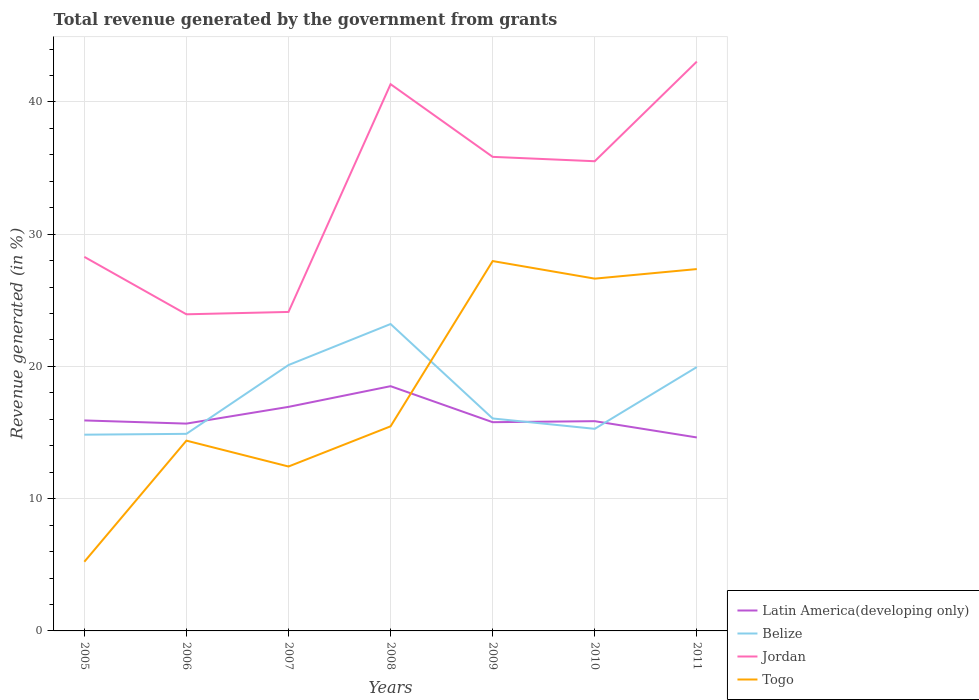Does the line corresponding to Togo intersect with the line corresponding to Jordan?
Provide a succinct answer. No. Across all years, what is the maximum total revenue generated in Togo?
Ensure brevity in your answer.  5.23. What is the total total revenue generated in Jordan in the graph?
Your answer should be very brief. -7.54. What is the difference between the highest and the second highest total revenue generated in Latin America(developing only)?
Ensure brevity in your answer.  3.88. Is the total revenue generated in Latin America(developing only) strictly greater than the total revenue generated in Jordan over the years?
Provide a short and direct response. Yes. Are the values on the major ticks of Y-axis written in scientific E-notation?
Your answer should be compact. No. What is the title of the graph?
Offer a terse response. Total revenue generated by the government from grants. Does "Cabo Verde" appear as one of the legend labels in the graph?
Your response must be concise. No. What is the label or title of the X-axis?
Ensure brevity in your answer.  Years. What is the label or title of the Y-axis?
Provide a succinct answer. Revenue generated (in %). What is the Revenue generated (in %) in Latin America(developing only) in 2005?
Your response must be concise. 15.92. What is the Revenue generated (in %) in Belize in 2005?
Provide a succinct answer. 14.84. What is the Revenue generated (in %) of Jordan in 2005?
Keep it short and to the point. 28.29. What is the Revenue generated (in %) in Togo in 2005?
Ensure brevity in your answer.  5.23. What is the Revenue generated (in %) of Latin America(developing only) in 2006?
Ensure brevity in your answer.  15.68. What is the Revenue generated (in %) in Belize in 2006?
Give a very brief answer. 14.9. What is the Revenue generated (in %) in Jordan in 2006?
Offer a very short reply. 23.94. What is the Revenue generated (in %) of Togo in 2006?
Offer a terse response. 14.39. What is the Revenue generated (in %) in Latin America(developing only) in 2007?
Keep it short and to the point. 16.94. What is the Revenue generated (in %) in Belize in 2007?
Offer a very short reply. 20.11. What is the Revenue generated (in %) in Jordan in 2007?
Make the answer very short. 24.12. What is the Revenue generated (in %) in Togo in 2007?
Offer a terse response. 12.43. What is the Revenue generated (in %) of Latin America(developing only) in 2008?
Keep it short and to the point. 18.51. What is the Revenue generated (in %) in Belize in 2008?
Keep it short and to the point. 23.21. What is the Revenue generated (in %) of Jordan in 2008?
Your response must be concise. 41.35. What is the Revenue generated (in %) in Togo in 2008?
Offer a terse response. 15.47. What is the Revenue generated (in %) of Latin America(developing only) in 2009?
Your answer should be very brief. 15.78. What is the Revenue generated (in %) in Belize in 2009?
Your answer should be compact. 16.07. What is the Revenue generated (in %) of Jordan in 2009?
Offer a very short reply. 35.85. What is the Revenue generated (in %) of Togo in 2009?
Your answer should be compact. 27.97. What is the Revenue generated (in %) of Latin America(developing only) in 2010?
Provide a succinct answer. 15.86. What is the Revenue generated (in %) in Belize in 2010?
Your response must be concise. 15.28. What is the Revenue generated (in %) in Jordan in 2010?
Offer a very short reply. 35.52. What is the Revenue generated (in %) in Togo in 2010?
Offer a terse response. 26.64. What is the Revenue generated (in %) in Latin America(developing only) in 2011?
Your response must be concise. 14.63. What is the Revenue generated (in %) in Belize in 2011?
Offer a terse response. 19.95. What is the Revenue generated (in %) of Jordan in 2011?
Your answer should be very brief. 43.05. What is the Revenue generated (in %) in Togo in 2011?
Ensure brevity in your answer.  27.36. Across all years, what is the maximum Revenue generated (in %) of Latin America(developing only)?
Your answer should be very brief. 18.51. Across all years, what is the maximum Revenue generated (in %) in Belize?
Your answer should be compact. 23.21. Across all years, what is the maximum Revenue generated (in %) in Jordan?
Offer a very short reply. 43.05. Across all years, what is the maximum Revenue generated (in %) in Togo?
Provide a short and direct response. 27.97. Across all years, what is the minimum Revenue generated (in %) in Latin America(developing only)?
Your answer should be very brief. 14.63. Across all years, what is the minimum Revenue generated (in %) in Belize?
Your response must be concise. 14.84. Across all years, what is the minimum Revenue generated (in %) of Jordan?
Provide a succinct answer. 23.94. Across all years, what is the minimum Revenue generated (in %) of Togo?
Ensure brevity in your answer.  5.23. What is the total Revenue generated (in %) in Latin America(developing only) in the graph?
Provide a short and direct response. 113.32. What is the total Revenue generated (in %) in Belize in the graph?
Give a very brief answer. 124.36. What is the total Revenue generated (in %) of Jordan in the graph?
Provide a short and direct response. 232.12. What is the total Revenue generated (in %) of Togo in the graph?
Make the answer very short. 129.5. What is the difference between the Revenue generated (in %) in Latin America(developing only) in 2005 and that in 2006?
Provide a succinct answer. 0.24. What is the difference between the Revenue generated (in %) of Belize in 2005 and that in 2006?
Provide a short and direct response. -0.06. What is the difference between the Revenue generated (in %) of Jordan in 2005 and that in 2006?
Ensure brevity in your answer.  4.34. What is the difference between the Revenue generated (in %) in Togo in 2005 and that in 2006?
Keep it short and to the point. -9.16. What is the difference between the Revenue generated (in %) in Latin America(developing only) in 2005 and that in 2007?
Make the answer very short. -1.03. What is the difference between the Revenue generated (in %) in Belize in 2005 and that in 2007?
Provide a short and direct response. -5.27. What is the difference between the Revenue generated (in %) of Jordan in 2005 and that in 2007?
Provide a succinct answer. 4.16. What is the difference between the Revenue generated (in %) of Togo in 2005 and that in 2007?
Ensure brevity in your answer.  -7.2. What is the difference between the Revenue generated (in %) of Latin America(developing only) in 2005 and that in 2008?
Your answer should be very brief. -2.59. What is the difference between the Revenue generated (in %) of Belize in 2005 and that in 2008?
Provide a succinct answer. -8.37. What is the difference between the Revenue generated (in %) of Jordan in 2005 and that in 2008?
Make the answer very short. -13.06. What is the difference between the Revenue generated (in %) in Togo in 2005 and that in 2008?
Your answer should be compact. -10.24. What is the difference between the Revenue generated (in %) in Latin America(developing only) in 2005 and that in 2009?
Offer a very short reply. 0.13. What is the difference between the Revenue generated (in %) of Belize in 2005 and that in 2009?
Offer a very short reply. -1.23. What is the difference between the Revenue generated (in %) in Jordan in 2005 and that in 2009?
Offer a terse response. -7.56. What is the difference between the Revenue generated (in %) of Togo in 2005 and that in 2009?
Offer a very short reply. -22.74. What is the difference between the Revenue generated (in %) of Latin America(developing only) in 2005 and that in 2010?
Your response must be concise. 0.06. What is the difference between the Revenue generated (in %) of Belize in 2005 and that in 2010?
Give a very brief answer. -0.44. What is the difference between the Revenue generated (in %) of Jordan in 2005 and that in 2010?
Make the answer very short. -7.23. What is the difference between the Revenue generated (in %) of Togo in 2005 and that in 2010?
Offer a terse response. -21.41. What is the difference between the Revenue generated (in %) of Latin America(developing only) in 2005 and that in 2011?
Ensure brevity in your answer.  1.29. What is the difference between the Revenue generated (in %) of Belize in 2005 and that in 2011?
Offer a terse response. -5.11. What is the difference between the Revenue generated (in %) in Jordan in 2005 and that in 2011?
Keep it short and to the point. -14.77. What is the difference between the Revenue generated (in %) of Togo in 2005 and that in 2011?
Provide a succinct answer. -22.13. What is the difference between the Revenue generated (in %) in Latin America(developing only) in 2006 and that in 2007?
Provide a succinct answer. -1.26. What is the difference between the Revenue generated (in %) in Belize in 2006 and that in 2007?
Keep it short and to the point. -5.2. What is the difference between the Revenue generated (in %) in Jordan in 2006 and that in 2007?
Your response must be concise. -0.18. What is the difference between the Revenue generated (in %) of Togo in 2006 and that in 2007?
Offer a terse response. 1.96. What is the difference between the Revenue generated (in %) of Latin America(developing only) in 2006 and that in 2008?
Give a very brief answer. -2.83. What is the difference between the Revenue generated (in %) in Belize in 2006 and that in 2008?
Provide a succinct answer. -8.3. What is the difference between the Revenue generated (in %) of Jordan in 2006 and that in 2008?
Your answer should be compact. -17.4. What is the difference between the Revenue generated (in %) in Togo in 2006 and that in 2008?
Provide a succinct answer. -1.08. What is the difference between the Revenue generated (in %) in Latin America(developing only) in 2006 and that in 2009?
Your answer should be very brief. -0.11. What is the difference between the Revenue generated (in %) in Belize in 2006 and that in 2009?
Your response must be concise. -1.16. What is the difference between the Revenue generated (in %) of Jordan in 2006 and that in 2009?
Provide a succinct answer. -11.91. What is the difference between the Revenue generated (in %) in Togo in 2006 and that in 2009?
Provide a succinct answer. -13.58. What is the difference between the Revenue generated (in %) of Latin America(developing only) in 2006 and that in 2010?
Offer a very short reply. -0.18. What is the difference between the Revenue generated (in %) in Belize in 2006 and that in 2010?
Your answer should be very brief. -0.38. What is the difference between the Revenue generated (in %) of Jordan in 2006 and that in 2010?
Make the answer very short. -11.58. What is the difference between the Revenue generated (in %) in Togo in 2006 and that in 2010?
Keep it short and to the point. -12.25. What is the difference between the Revenue generated (in %) of Latin America(developing only) in 2006 and that in 2011?
Your answer should be compact. 1.05. What is the difference between the Revenue generated (in %) in Belize in 2006 and that in 2011?
Provide a short and direct response. -5.05. What is the difference between the Revenue generated (in %) of Jordan in 2006 and that in 2011?
Offer a very short reply. -19.11. What is the difference between the Revenue generated (in %) of Togo in 2006 and that in 2011?
Ensure brevity in your answer.  -12.97. What is the difference between the Revenue generated (in %) in Latin America(developing only) in 2007 and that in 2008?
Give a very brief answer. -1.57. What is the difference between the Revenue generated (in %) of Belize in 2007 and that in 2008?
Offer a terse response. -3.1. What is the difference between the Revenue generated (in %) of Jordan in 2007 and that in 2008?
Your answer should be very brief. -17.22. What is the difference between the Revenue generated (in %) in Togo in 2007 and that in 2008?
Your answer should be very brief. -3.04. What is the difference between the Revenue generated (in %) of Latin America(developing only) in 2007 and that in 2009?
Your answer should be compact. 1.16. What is the difference between the Revenue generated (in %) of Belize in 2007 and that in 2009?
Offer a terse response. 4.04. What is the difference between the Revenue generated (in %) in Jordan in 2007 and that in 2009?
Your answer should be very brief. -11.73. What is the difference between the Revenue generated (in %) of Togo in 2007 and that in 2009?
Keep it short and to the point. -15.54. What is the difference between the Revenue generated (in %) of Latin America(developing only) in 2007 and that in 2010?
Ensure brevity in your answer.  1.08. What is the difference between the Revenue generated (in %) of Belize in 2007 and that in 2010?
Make the answer very short. 4.82. What is the difference between the Revenue generated (in %) of Jordan in 2007 and that in 2010?
Offer a terse response. -11.4. What is the difference between the Revenue generated (in %) of Togo in 2007 and that in 2010?
Ensure brevity in your answer.  -14.21. What is the difference between the Revenue generated (in %) of Latin America(developing only) in 2007 and that in 2011?
Ensure brevity in your answer.  2.31. What is the difference between the Revenue generated (in %) of Belize in 2007 and that in 2011?
Provide a short and direct response. 0.15. What is the difference between the Revenue generated (in %) in Jordan in 2007 and that in 2011?
Offer a very short reply. -18.93. What is the difference between the Revenue generated (in %) of Togo in 2007 and that in 2011?
Your answer should be very brief. -14.93. What is the difference between the Revenue generated (in %) in Latin America(developing only) in 2008 and that in 2009?
Give a very brief answer. 2.72. What is the difference between the Revenue generated (in %) of Belize in 2008 and that in 2009?
Provide a succinct answer. 7.14. What is the difference between the Revenue generated (in %) in Jordan in 2008 and that in 2009?
Your answer should be compact. 5.5. What is the difference between the Revenue generated (in %) of Togo in 2008 and that in 2009?
Make the answer very short. -12.5. What is the difference between the Revenue generated (in %) in Latin America(developing only) in 2008 and that in 2010?
Your answer should be very brief. 2.65. What is the difference between the Revenue generated (in %) in Belize in 2008 and that in 2010?
Keep it short and to the point. 7.93. What is the difference between the Revenue generated (in %) in Jordan in 2008 and that in 2010?
Keep it short and to the point. 5.83. What is the difference between the Revenue generated (in %) of Togo in 2008 and that in 2010?
Your answer should be compact. -11.17. What is the difference between the Revenue generated (in %) of Latin America(developing only) in 2008 and that in 2011?
Ensure brevity in your answer.  3.88. What is the difference between the Revenue generated (in %) of Belize in 2008 and that in 2011?
Provide a short and direct response. 3.25. What is the difference between the Revenue generated (in %) in Jordan in 2008 and that in 2011?
Offer a terse response. -1.71. What is the difference between the Revenue generated (in %) of Togo in 2008 and that in 2011?
Your response must be concise. -11.89. What is the difference between the Revenue generated (in %) of Latin America(developing only) in 2009 and that in 2010?
Ensure brevity in your answer.  -0.08. What is the difference between the Revenue generated (in %) in Belize in 2009 and that in 2010?
Give a very brief answer. 0.78. What is the difference between the Revenue generated (in %) in Jordan in 2009 and that in 2010?
Keep it short and to the point. 0.33. What is the difference between the Revenue generated (in %) of Togo in 2009 and that in 2010?
Provide a succinct answer. 1.33. What is the difference between the Revenue generated (in %) of Latin America(developing only) in 2009 and that in 2011?
Give a very brief answer. 1.15. What is the difference between the Revenue generated (in %) of Belize in 2009 and that in 2011?
Provide a succinct answer. -3.89. What is the difference between the Revenue generated (in %) of Jordan in 2009 and that in 2011?
Offer a very short reply. -7.21. What is the difference between the Revenue generated (in %) of Togo in 2009 and that in 2011?
Your answer should be very brief. 0.61. What is the difference between the Revenue generated (in %) in Latin America(developing only) in 2010 and that in 2011?
Make the answer very short. 1.23. What is the difference between the Revenue generated (in %) in Belize in 2010 and that in 2011?
Your answer should be very brief. -4.67. What is the difference between the Revenue generated (in %) in Jordan in 2010 and that in 2011?
Give a very brief answer. -7.54. What is the difference between the Revenue generated (in %) in Togo in 2010 and that in 2011?
Provide a short and direct response. -0.72. What is the difference between the Revenue generated (in %) of Latin America(developing only) in 2005 and the Revenue generated (in %) of Belize in 2006?
Your answer should be very brief. 1.01. What is the difference between the Revenue generated (in %) of Latin America(developing only) in 2005 and the Revenue generated (in %) of Jordan in 2006?
Make the answer very short. -8.03. What is the difference between the Revenue generated (in %) of Latin America(developing only) in 2005 and the Revenue generated (in %) of Togo in 2006?
Offer a terse response. 1.53. What is the difference between the Revenue generated (in %) of Belize in 2005 and the Revenue generated (in %) of Jordan in 2006?
Your response must be concise. -9.1. What is the difference between the Revenue generated (in %) in Belize in 2005 and the Revenue generated (in %) in Togo in 2006?
Keep it short and to the point. 0.45. What is the difference between the Revenue generated (in %) of Jordan in 2005 and the Revenue generated (in %) of Togo in 2006?
Offer a very short reply. 13.9. What is the difference between the Revenue generated (in %) of Latin America(developing only) in 2005 and the Revenue generated (in %) of Belize in 2007?
Provide a succinct answer. -4.19. What is the difference between the Revenue generated (in %) in Latin America(developing only) in 2005 and the Revenue generated (in %) in Jordan in 2007?
Ensure brevity in your answer.  -8.2. What is the difference between the Revenue generated (in %) of Latin America(developing only) in 2005 and the Revenue generated (in %) of Togo in 2007?
Offer a very short reply. 3.48. What is the difference between the Revenue generated (in %) of Belize in 2005 and the Revenue generated (in %) of Jordan in 2007?
Make the answer very short. -9.28. What is the difference between the Revenue generated (in %) in Belize in 2005 and the Revenue generated (in %) in Togo in 2007?
Give a very brief answer. 2.41. What is the difference between the Revenue generated (in %) of Jordan in 2005 and the Revenue generated (in %) of Togo in 2007?
Give a very brief answer. 15.85. What is the difference between the Revenue generated (in %) of Latin America(developing only) in 2005 and the Revenue generated (in %) of Belize in 2008?
Make the answer very short. -7.29. What is the difference between the Revenue generated (in %) in Latin America(developing only) in 2005 and the Revenue generated (in %) in Jordan in 2008?
Your answer should be very brief. -25.43. What is the difference between the Revenue generated (in %) of Latin America(developing only) in 2005 and the Revenue generated (in %) of Togo in 2008?
Keep it short and to the point. 0.45. What is the difference between the Revenue generated (in %) of Belize in 2005 and the Revenue generated (in %) of Jordan in 2008?
Offer a terse response. -26.51. What is the difference between the Revenue generated (in %) of Belize in 2005 and the Revenue generated (in %) of Togo in 2008?
Make the answer very short. -0.63. What is the difference between the Revenue generated (in %) of Jordan in 2005 and the Revenue generated (in %) of Togo in 2008?
Ensure brevity in your answer.  12.81. What is the difference between the Revenue generated (in %) in Latin America(developing only) in 2005 and the Revenue generated (in %) in Belize in 2009?
Give a very brief answer. -0.15. What is the difference between the Revenue generated (in %) in Latin America(developing only) in 2005 and the Revenue generated (in %) in Jordan in 2009?
Provide a succinct answer. -19.93. What is the difference between the Revenue generated (in %) of Latin America(developing only) in 2005 and the Revenue generated (in %) of Togo in 2009?
Ensure brevity in your answer.  -12.05. What is the difference between the Revenue generated (in %) in Belize in 2005 and the Revenue generated (in %) in Jordan in 2009?
Make the answer very short. -21.01. What is the difference between the Revenue generated (in %) in Belize in 2005 and the Revenue generated (in %) in Togo in 2009?
Your answer should be compact. -13.13. What is the difference between the Revenue generated (in %) in Jordan in 2005 and the Revenue generated (in %) in Togo in 2009?
Provide a succinct answer. 0.32. What is the difference between the Revenue generated (in %) in Latin America(developing only) in 2005 and the Revenue generated (in %) in Belize in 2010?
Ensure brevity in your answer.  0.63. What is the difference between the Revenue generated (in %) in Latin America(developing only) in 2005 and the Revenue generated (in %) in Jordan in 2010?
Ensure brevity in your answer.  -19.6. What is the difference between the Revenue generated (in %) of Latin America(developing only) in 2005 and the Revenue generated (in %) of Togo in 2010?
Your answer should be compact. -10.72. What is the difference between the Revenue generated (in %) in Belize in 2005 and the Revenue generated (in %) in Jordan in 2010?
Offer a very short reply. -20.68. What is the difference between the Revenue generated (in %) in Belize in 2005 and the Revenue generated (in %) in Togo in 2010?
Your answer should be compact. -11.8. What is the difference between the Revenue generated (in %) in Jordan in 2005 and the Revenue generated (in %) in Togo in 2010?
Provide a succinct answer. 1.65. What is the difference between the Revenue generated (in %) of Latin America(developing only) in 2005 and the Revenue generated (in %) of Belize in 2011?
Offer a very short reply. -4.04. What is the difference between the Revenue generated (in %) in Latin America(developing only) in 2005 and the Revenue generated (in %) in Jordan in 2011?
Ensure brevity in your answer.  -27.14. What is the difference between the Revenue generated (in %) of Latin America(developing only) in 2005 and the Revenue generated (in %) of Togo in 2011?
Your response must be concise. -11.45. What is the difference between the Revenue generated (in %) in Belize in 2005 and the Revenue generated (in %) in Jordan in 2011?
Ensure brevity in your answer.  -28.21. What is the difference between the Revenue generated (in %) of Belize in 2005 and the Revenue generated (in %) of Togo in 2011?
Your answer should be compact. -12.52. What is the difference between the Revenue generated (in %) of Jordan in 2005 and the Revenue generated (in %) of Togo in 2011?
Your answer should be very brief. 0.92. What is the difference between the Revenue generated (in %) of Latin America(developing only) in 2006 and the Revenue generated (in %) of Belize in 2007?
Your response must be concise. -4.43. What is the difference between the Revenue generated (in %) in Latin America(developing only) in 2006 and the Revenue generated (in %) in Jordan in 2007?
Keep it short and to the point. -8.44. What is the difference between the Revenue generated (in %) of Latin America(developing only) in 2006 and the Revenue generated (in %) of Togo in 2007?
Provide a succinct answer. 3.24. What is the difference between the Revenue generated (in %) of Belize in 2006 and the Revenue generated (in %) of Jordan in 2007?
Your response must be concise. -9.22. What is the difference between the Revenue generated (in %) in Belize in 2006 and the Revenue generated (in %) in Togo in 2007?
Provide a succinct answer. 2.47. What is the difference between the Revenue generated (in %) of Jordan in 2006 and the Revenue generated (in %) of Togo in 2007?
Keep it short and to the point. 11.51. What is the difference between the Revenue generated (in %) in Latin America(developing only) in 2006 and the Revenue generated (in %) in Belize in 2008?
Offer a terse response. -7.53. What is the difference between the Revenue generated (in %) of Latin America(developing only) in 2006 and the Revenue generated (in %) of Jordan in 2008?
Your answer should be compact. -25.67. What is the difference between the Revenue generated (in %) of Latin America(developing only) in 2006 and the Revenue generated (in %) of Togo in 2008?
Give a very brief answer. 0.21. What is the difference between the Revenue generated (in %) of Belize in 2006 and the Revenue generated (in %) of Jordan in 2008?
Give a very brief answer. -26.44. What is the difference between the Revenue generated (in %) of Belize in 2006 and the Revenue generated (in %) of Togo in 2008?
Keep it short and to the point. -0.57. What is the difference between the Revenue generated (in %) of Jordan in 2006 and the Revenue generated (in %) of Togo in 2008?
Provide a short and direct response. 8.47. What is the difference between the Revenue generated (in %) in Latin America(developing only) in 2006 and the Revenue generated (in %) in Belize in 2009?
Ensure brevity in your answer.  -0.39. What is the difference between the Revenue generated (in %) in Latin America(developing only) in 2006 and the Revenue generated (in %) in Jordan in 2009?
Offer a terse response. -20.17. What is the difference between the Revenue generated (in %) in Latin America(developing only) in 2006 and the Revenue generated (in %) in Togo in 2009?
Give a very brief answer. -12.29. What is the difference between the Revenue generated (in %) of Belize in 2006 and the Revenue generated (in %) of Jordan in 2009?
Ensure brevity in your answer.  -20.95. What is the difference between the Revenue generated (in %) in Belize in 2006 and the Revenue generated (in %) in Togo in 2009?
Your answer should be compact. -13.07. What is the difference between the Revenue generated (in %) in Jordan in 2006 and the Revenue generated (in %) in Togo in 2009?
Your answer should be compact. -4.03. What is the difference between the Revenue generated (in %) of Latin America(developing only) in 2006 and the Revenue generated (in %) of Belize in 2010?
Give a very brief answer. 0.4. What is the difference between the Revenue generated (in %) in Latin America(developing only) in 2006 and the Revenue generated (in %) in Jordan in 2010?
Your answer should be very brief. -19.84. What is the difference between the Revenue generated (in %) of Latin America(developing only) in 2006 and the Revenue generated (in %) of Togo in 2010?
Provide a succinct answer. -10.96. What is the difference between the Revenue generated (in %) in Belize in 2006 and the Revenue generated (in %) in Jordan in 2010?
Offer a terse response. -20.62. What is the difference between the Revenue generated (in %) in Belize in 2006 and the Revenue generated (in %) in Togo in 2010?
Your response must be concise. -11.74. What is the difference between the Revenue generated (in %) in Jordan in 2006 and the Revenue generated (in %) in Togo in 2010?
Ensure brevity in your answer.  -2.7. What is the difference between the Revenue generated (in %) in Latin America(developing only) in 2006 and the Revenue generated (in %) in Belize in 2011?
Give a very brief answer. -4.28. What is the difference between the Revenue generated (in %) in Latin America(developing only) in 2006 and the Revenue generated (in %) in Jordan in 2011?
Offer a very short reply. -27.38. What is the difference between the Revenue generated (in %) in Latin America(developing only) in 2006 and the Revenue generated (in %) in Togo in 2011?
Make the answer very short. -11.69. What is the difference between the Revenue generated (in %) in Belize in 2006 and the Revenue generated (in %) in Jordan in 2011?
Make the answer very short. -28.15. What is the difference between the Revenue generated (in %) of Belize in 2006 and the Revenue generated (in %) of Togo in 2011?
Make the answer very short. -12.46. What is the difference between the Revenue generated (in %) in Jordan in 2006 and the Revenue generated (in %) in Togo in 2011?
Offer a terse response. -3.42. What is the difference between the Revenue generated (in %) of Latin America(developing only) in 2007 and the Revenue generated (in %) of Belize in 2008?
Provide a succinct answer. -6.27. What is the difference between the Revenue generated (in %) of Latin America(developing only) in 2007 and the Revenue generated (in %) of Jordan in 2008?
Your answer should be compact. -24.4. What is the difference between the Revenue generated (in %) in Latin America(developing only) in 2007 and the Revenue generated (in %) in Togo in 2008?
Provide a short and direct response. 1.47. What is the difference between the Revenue generated (in %) of Belize in 2007 and the Revenue generated (in %) of Jordan in 2008?
Offer a terse response. -21.24. What is the difference between the Revenue generated (in %) in Belize in 2007 and the Revenue generated (in %) in Togo in 2008?
Give a very brief answer. 4.63. What is the difference between the Revenue generated (in %) of Jordan in 2007 and the Revenue generated (in %) of Togo in 2008?
Provide a succinct answer. 8.65. What is the difference between the Revenue generated (in %) in Latin America(developing only) in 2007 and the Revenue generated (in %) in Belize in 2009?
Offer a terse response. 0.88. What is the difference between the Revenue generated (in %) of Latin America(developing only) in 2007 and the Revenue generated (in %) of Jordan in 2009?
Your answer should be compact. -18.91. What is the difference between the Revenue generated (in %) of Latin America(developing only) in 2007 and the Revenue generated (in %) of Togo in 2009?
Give a very brief answer. -11.03. What is the difference between the Revenue generated (in %) of Belize in 2007 and the Revenue generated (in %) of Jordan in 2009?
Provide a short and direct response. -15.74. What is the difference between the Revenue generated (in %) in Belize in 2007 and the Revenue generated (in %) in Togo in 2009?
Make the answer very short. -7.86. What is the difference between the Revenue generated (in %) in Jordan in 2007 and the Revenue generated (in %) in Togo in 2009?
Your response must be concise. -3.85. What is the difference between the Revenue generated (in %) in Latin America(developing only) in 2007 and the Revenue generated (in %) in Belize in 2010?
Provide a short and direct response. 1.66. What is the difference between the Revenue generated (in %) of Latin America(developing only) in 2007 and the Revenue generated (in %) of Jordan in 2010?
Give a very brief answer. -18.58. What is the difference between the Revenue generated (in %) in Latin America(developing only) in 2007 and the Revenue generated (in %) in Togo in 2010?
Your response must be concise. -9.7. What is the difference between the Revenue generated (in %) of Belize in 2007 and the Revenue generated (in %) of Jordan in 2010?
Your response must be concise. -15.41. What is the difference between the Revenue generated (in %) in Belize in 2007 and the Revenue generated (in %) in Togo in 2010?
Your answer should be compact. -6.53. What is the difference between the Revenue generated (in %) in Jordan in 2007 and the Revenue generated (in %) in Togo in 2010?
Your answer should be very brief. -2.52. What is the difference between the Revenue generated (in %) in Latin America(developing only) in 2007 and the Revenue generated (in %) in Belize in 2011?
Keep it short and to the point. -3.01. What is the difference between the Revenue generated (in %) in Latin America(developing only) in 2007 and the Revenue generated (in %) in Jordan in 2011?
Your answer should be very brief. -26.11. What is the difference between the Revenue generated (in %) in Latin America(developing only) in 2007 and the Revenue generated (in %) in Togo in 2011?
Give a very brief answer. -10.42. What is the difference between the Revenue generated (in %) in Belize in 2007 and the Revenue generated (in %) in Jordan in 2011?
Offer a terse response. -22.95. What is the difference between the Revenue generated (in %) of Belize in 2007 and the Revenue generated (in %) of Togo in 2011?
Give a very brief answer. -7.26. What is the difference between the Revenue generated (in %) of Jordan in 2007 and the Revenue generated (in %) of Togo in 2011?
Ensure brevity in your answer.  -3.24. What is the difference between the Revenue generated (in %) of Latin America(developing only) in 2008 and the Revenue generated (in %) of Belize in 2009?
Keep it short and to the point. 2.44. What is the difference between the Revenue generated (in %) of Latin America(developing only) in 2008 and the Revenue generated (in %) of Jordan in 2009?
Offer a terse response. -17.34. What is the difference between the Revenue generated (in %) of Latin America(developing only) in 2008 and the Revenue generated (in %) of Togo in 2009?
Offer a very short reply. -9.46. What is the difference between the Revenue generated (in %) of Belize in 2008 and the Revenue generated (in %) of Jordan in 2009?
Offer a terse response. -12.64. What is the difference between the Revenue generated (in %) of Belize in 2008 and the Revenue generated (in %) of Togo in 2009?
Make the answer very short. -4.76. What is the difference between the Revenue generated (in %) in Jordan in 2008 and the Revenue generated (in %) in Togo in 2009?
Keep it short and to the point. 13.38. What is the difference between the Revenue generated (in %) in Latin America(developing only) in 2008 and the Revenue generated (in %) in Belize in 2010?
Your response must be concise. 3.23. What is the difference between the Revenue generated (in %) in Latin America(developing only) in 2008 and the Revenue generated (in %) in Jordan in 2010?
Ensure brevity in your answer.  -17.01. What is the difference between the Revenue generated (in %) in Latin America(developing only) in 2008 and the Revenue generated (in %) in Togo in 2010?
Provide a succinct answer. -8.13. What is the difference between the Revenue generated (in %) in Belize in 2008 and the Revenue generated (in %) in Jordan in 2010?
Give a very brief answer. -12.31. What is the difference between the Revenue generated (in %) in Belize in 2008 and the Revenue generated (in %) in Togo in 2010?
Your response must be concise. -3.43. What is the difference between the Revenue generated (in %) in Jordan in 2008 and the Revenue generated (in %) in Togo in 2010?
Offer a terse response. 14.71. What is the difference between the Revenue generated (in %) of Latin America(developing only) in 2008 and the Revenue generated (in %) of Belize in 2011?
Offer a very short reply. -1.45. What is the difference between the Revenue generated (in %) of Latin America(developing only) in 2008 and the Revenue generated (in %) of Jordan in 2011?
Your answer should be compact. -24.55. What is the difference between the Revenue generated (in %) of Latin America(developing only) in 2008 and the Revenue generated (in %) of Togo in 2011?
Ensure brevity in your answer.  -8.86. What is the difference between the Revenue generated (in %) of Belize in 2008 and the Revenue generated (in %) of Jordan in 2011?
Provide a short and direct response. -19.85. What is the difference between the Revenue generated (in %) of Belize in 2008 and the Revenue generated (in %) of Togo in 2011?
Offer a terse response. -4.16. What is the difference between the Revenue generated (in %) in Jordan in 2008 and the Revenue generated (in %) in Togo in 2011?
Ensure brevity in your answer.  13.98. What is the difference between the Revenue generated (in %) of Latin America(developing only) in 2009 and the Revenue generated (in %) of Belize in 2010?
Ensure brevity in your answer.  0.5. What is the difference between the Revenue generated (in %) of Latin America(developing only) in 2009 and the Revenue generated (in %) of Jordan in 2010?
Ensure brevity in your answer.  -19.73. What is the difference between the Revenue generated (in %) of Latin America(developing only) in 2009 and the Revenue generated (in %) of Togo in 2010?
Offer a terse response. -10.86. What is the difference between the Revenue generated (in %) in Belize in 2009 and the Revenue generated (in %) in Jordan in 2010?
Your response must be concise. -19.45. What is the difference between the Revenue generated (in %) of Belize in 2009 and the Revenue generated (in %) of Togo in 2010?
Give a very brief answer. -10.57. What is the difference between the Revenue generated (in %) of Jordan in 2009 and the Revenue generated (in %) of Togo in 2010?
Keep it short and to the point. 9.21. What is the difference between the Revenue generated (in %) of Latin America(developing only) in 2009 and the Revenue generated (in %) of Belize in 2011?
Offer a very short reply. -4.17. What is the difference between the Revenue generated (in %) of Latin America(developing only) in 2009 and the Revenue generated (in %) of Jordan in 2011?
Your response must be concise. -27.27. What is the difference between the Revenue generated (in %) of Latin America(developing only) in 2009 and the Revenue generated (in %) of Togo in 2011?
Ensure brevity in your answer.  -11.58. What is the difference between the Revenue generated (in %) in Belize in 2009 and the Revenue generated (in %) in Jordan in 2011?
Ensure brevity in your answer.  -26.99. What is the difference between the Revenue generated (in %) of Belize in 2009 and the Revenue generated (in %) of Togo in 2011?
Keep it short and to the point. -11.3. What is the difference between the Revenue generated (in %) of Jordan in 2009 and the Revenue generated (in %) of Togo in 2011?
Keep it short and to the point. 8.49. What is the difference between the Revenue generated (in %) of Latin America(developing only) in 2010 and the Revenue generated (in %) of Belize in 2011?
Your answer should be very brief. -4.09. What is the difference between the Revenue generated (in %) in Latin America(developing only) in 2010 and the Revenue generated (in %) in Jordan in 2011?
Offer a terse response. -27.19. What is the difference between the Revenue generated (in %) of Latin America(developing only) in 2010 and the Revenue generated (in %) of Togo in 2011?
Give a very brief answer. -11.5. What is the difference between the Revenue generated (in %) of Belize in 2010 and the Revenue generated (in %) of Jordan in 2011?
Ensure brevity in your answer.  -27.77. What is the difference between the Revenue generated (in %) of Belize in 2010 and the Revenue generated (in %) of Togo in 2011?
Offer a very short reply. -12.08. What is the difference between the Revenue generated (in %) in Jordan in 2010 and the Revenue generated (in %) in Togo in 2011?
Your answer should be very brief. 8.15. What is the average Revenue generated (in %) in Latin America(developing only) per year?
Offer a terse response. 16.19. What is the average Revenue generated (in %) in Belize per year?
Provide a short and direct response. 17.77. What is the average Revenue generated (in %) of Jordan per year?
Keep it short and to the point. 33.16. What is the average Revenue generated (in %) of Togo per year?
Your response must be concise. 18.5. In the year 2005, what is the difference between the Revenue generated (in %) of Latin America(developing only) and Revenue generated (in %) of Belize?
Your answer should be compact. 1.08. In the year 2005, what is the difference between the Revenue generated (in %) in Latin America(developing only) and Revenue generated (in %) in Jordan?
Your answer should be very brief. -12.37. In the year 2005, what is the difference between the Revenue generated (in %) in Latin America(developing only) and Revenue generated (in %) in Togo?
Give a very brief answer. 10.69. In the year 2005, what is the difference between the Revenue generated (in %) in Belize and Revenue generated (in %) in Jordan?
Your response must be concise. -13.45. In the year 2005, what is the difference between the Revenue generated (in %) in Belize and Revenue generated (in %) in Togo?
Give a very brief answer. 9.61. In the year 2005, what is the difference between the Revenue generated (in %) in Jordan and Revenue generated (in %) in Togo?
Your response must be concise. 23.06. In the year 2006, what is the difference between the Revenue generated (in %) in Latin America(developing only) and Revenue generated (in %) in Belize?
Offer a terse response. 0.77. In the year 2006, what is the difference between the Revenue generated (in %) of Latin America(developing only) and Revenue generated (in %) of Jordan?
Your response must be concise. -8.27. In the year 2006, what is the difference between the Revenue generated (in %) in Latin America(developing only) and Revenue generated (in %) in Togo?
Your response must be concise. 1.29. In the year 2006, what is the difference between the Revenue generated (in %) of Belize and Revenue generated (in %) of Jordan?
Make the answer very short. -9.04. In the year 2006, what is the difference between the Revenue generated (in %) in Belize and Revenue generated (in %) in Togo?
Your response must be concise. 0.51. In the year 2006, what is the difference between the Revenue generated (in %) in Jordan and Revenue generated (in %) in Togo?
Give a very brief answer. 9.55. In the year 2007, what is the difference between the Revenue generated (in %) of Latin America(developing only) and Revenue generated (in %) of Belize?
Provide a short and direct response. -3.16. In the year 2007, what is the difference between the Revenue generated (in %) of Latin America(developing only) and Revenue generated (in %) of Jordan?
Offer a terse response. -7.18. In the year 2007, what is the difference between the Revenue generated (in %) in Latin America(developing only) and Revenue generated (in %) in Togo?
Make the answer very short. 4.51. In the year 2007, what is the difference between the Revenue generated (in %) in Belize and Revenue generated (in %) in Jordan?
Provide a short and direct response. -4.02. In the year 2007, what is the difference between the Revenue generated (in %) in Belize and Revenue generated (in %) in Togo?
Your answer should be compact. 7.67. In the year 2007, what is the difference between the Revenue generated (in %) in Jordan and Revenue generated (in %) in Togo?
Offer a very short reply. 11.69. In the year 2008, what is the difference between the Revenue generated (in %) in Latin America(developing only) and Revenue generated (in %) in Belize?
Keep it short and to the point. -4.7. In the year 2008, what is the difference between the Revenue generated (in %) of Latin America(developing only) and Revenue generated (in %) of Jordan?
Keep it short and to the point. -22.84. In the year 2008, what is the difference between the Revenue generated (in %) in Latin America(developing only) and Revenue generated (in %) in Togo?
Offer a terse response. 3.04. In the year 2008, what is the difference between the Revenue generated (in %) of Belize and Revenue generated (in %) of Jordan?
Make the answer very short. -18.14. In the year 2008, what is the difference between the Revenue generated (in %) in Belize and Revenue generated (in %) in Togo?
Offer a very short reply. 7.74. In the year 2008, what is the difference between the Revenue generated (in %) in Jordan and Revenue generated (in %) in Togo?
Your answer should be compact. 25.87. In the year 2009, what is the difference between the Revenue generated (in %) in Latin America(developing only) and Revenue generated (in %) in Belize?
Provide a short and direct response. -0.28. In the year 2009, what is the difference between the Revenue generated (in %) in Latin America(developing only) and Revenue generated (in %) in Jordan?
Offer a terse response. -20.06. In the year 2009, what is the difference between the Revenue generated (in %) in Latin America(developing only) and Revenue generated (in %) in Togo?
Keep it short and to the point. -12.18. In the year 2009, what is the difference between the Revenue generated (in %) of Belize and Revenue generated (in %) of Jordan?
Make the answer very short. -19.78. In the year 2009, what is the difference between the Revenue generated (in %) of Belize and Revenue generated (in %) of Togo?
Keep it short and to the point. -11.9. In the year 2009, what is the difference between the Revenue generated (in %) in Jordan and Revenue generated (in %) in Togo?
Ensure brevity in your answer.  7.88. In the year 2010, what is the difference between the Revenue generated (in %) of Latin America(developing only) and Revenue generated (in %) of Belize?
Keep it short and to the point. 0.58. In the year 2010, what is the difference between the Revenue generated (in %) in Latin America(developing only) and Revenue generated (in %) in Jordan?
Provide a short and direct response. -19.66. In the year 2010, what is the difference between the Revenue generated (in %) in Latin America(developing only) and Revenue generated (in %) in Togo?
Your answer should be compact. -10.78. In the year 2010, what is the difference between the Revenue generated (in %) in Belize and Revenue generated (in %) in Jordan?
Keep it short and to the point. -20.24. In the year 2010, what is the difference between the Revenue generated (in %) of Belize and Revenue generated (in %) of Togo?
Give a very brief answer. -11.36. In the year 2010, what is the difference between the Revenue generated (in %) of Jordan and Revenue generated (in %) of Togo?
Provide a short and direct response. 8.88. In the year 2011, what is the difference between the Revenue generated (in %) in Latin America(developing only) and Revenue generated (in %) in Belize?
Provide a short and direct response. -5.32. In the year 2011, what is the difference between the Revenue generated (in %) in Latin America(developing only) and Revenue generated (in %) in Jordan?
Provide a short and direct response. -28.42. In the year 2011, what is the difference between the Revenue generated (in %) in Latin America(developing only) and Revenue generated (in %) in Togo?
Your response must be concise. -12.73. In the year 2011, what is the difference between the Revenue generated (in %) in Belize and Revenue generated (in %) in Jordan?
Provide a succinct answer. -23.1. In the year 2011, what is the difference between the Revenue generated (in %) in Belize and Revenue generated (in %) in Togo?
Offer a terse response. -7.41. In the year 2011, what is the difference between the Revenue generated (in %) in Jordan and Revenue generated (in %) in Togo?
Your answer should be compact. 15.69. What is the ratio of the Revenue generated (in %) in Latin America(developing only) in 2005 to that in 2006?
Make the answer very short. 1.02. What is the ratio of the Revenue generated (in %) of Belize in 2005 to that in 2006?
Give a very brief answer. 1. What is the ratio of the Revenue generated (in %) of Jordan in 2005 to that in 2006?
Offer a very short reply. 1.18. What is the ratio of the Revenue generated (in %) in Togo in 2005 to that in 2006?
Your response must be concise. 0.36. What is the ratio of the Revenue generated (in %) in Latin America(developing only) in 2005 to that in 2007?
Keep it short and to the point. 0.94. What is the ratio of the Revenue generated (in %) in Belize in 2005 to that in 2007?
Give a very brief answer. 0.74. What is the ratio of the Revenue generated (in %) of Jordan in 2005 to that in 2007?
Make the answer very short. 1.17. What is the ratio of the Revenue generated (in %) in Togo in 2005 to that in 2007?
Provide a succinct answer. 0.42. What is the ratio of the Revenue generated (in %) in Latin America(developing only) in 2005 to that in 2008?
Ensure brevity in your answer.  0.86. What is the ratio of the Revenue generated (in %) of Belize in 2005 to that in 2008?
Provide a short and direct response. 0.64. What is the ratio of the Revenue generated (in %) of Jordan in 2005 to that in 2008?
Ensure brevity in your answer.  0.68. What is the ratio of the Revenue generated (in %) of Togo in 2005 to that in 2008?
Offer a terse response. 0.34. What is the ratio of the Revenue generated (in %) in Latin America(developing only) in 2005 to that in 2009?
Offer a very short reply. 1.01. What is the ratio of the Revenue generated (in %) of Belize in 2005 to that in 2009?
Your answer should be compact. 0.92. What is the ratio of the Revenue generated (in %) in Jordan in 2005 to that in 2009?
Offer a very short reply. 0.79. What is the ratio of the Revenue generated (in %) in Togo in 2005 to that in 2009?
Your answer should be compact. 0.19. What is the ratio of the Revenue generated (in %) of Belize in 2005 to that in 2010?
Your answer should be compact. 0.97. What is the ratio of the Revenue generated (in %) of Jordan in 2005 to that in 2010?
Make the answer very short. 0.8. What is the ratio of the Revenue generated (in %) in Togo in 2005 to that in 2010?
Provide a short and direct response. 0.2. What is the ratio of the Revenue generated (in %) of Latin America(developing only) in 2005 to that in 2011?
Ensure brevity in your answer.  1.09. What is the ratio of the Revenue generated (in %) of Belize in 2005 to that in 2011?
Offer a terse response. 0.74. What is the ratio of the Revenue generated (in %) in Jordan in 2005 to that in 2011?
Your answer should be very brief. 0.66. What is the ratio of the Revenue generated (in %) in Togo in 2005 to that in 2011?
Your answer should be compact. 0.19. What is the ratio of the Revenue generated (in %) of Latin America(developing only) in 2006 to that in 2007?
Offer a terse response. 0.93. What is the ratio of the Revenue generated (in %) of Belize in 2006 to that in 2007?
Provide a succinct answer. 0.74. What is the ratio of the Revenue generated (in %) of Togo in 2006 to that in 2007?
Your response must be concise. 1.16. What is the ratio of the Revenue generated (in %) of Latin America(developing only) in 2006 to that in 2008?
Ensure brevity in your answer.  0.85. What is the ratio of the Revenue generated (in %) of Belize in 2006 to that in 2008?
Provide a succinct answer. 0.64. What is the ratio of the Revenue generated (in %) in Jordan in 2006 to that in 2008?
Offer a terse response. 0.58. What is the ratio of the Revenue generated (in %) of Latin America(developing only) in 2006 to that in 2009?
Your answer should be very brief. 0.99. What is the ratio of the Revenue generated (in %) of Belize in 2006 to that in 2009?
Provide a succinct answer. 0.93. What is the ratio of the Revenue generated (in %) in Jordan in 2006 to that in 2009?
Offer a very short reply. 0.67. What is the ratio of the Revenue generated (in %) in Togo in 2006 to that in 2009?
Make the answer very short. 0.51. What is the ratio of the Revenue generated (in %) in Latin America(developing only) in 2006 to that in 2010?
Give a very brief answer. 0.99. What is the ratio of the Revenue generated (in %) of Belize in 2006 to that in 2010?
Your answer should be very brief. 0.98. What is the ratio of the Revenue generated (in %) in Jordan in 2006 to that in 2010?
Provide a short and direct response. 0.67. What is the ratio of the Revenue generated (in %) of Togo in 2006 to that in 2010?
Keep it short and to the point. 0.54. What is the ratio of the Revenue generated (in %) of Latin America(developing only) in 2006 to that in 2011?
Keep it short and to the point. 1.07. What is the ratio of the Revenue generated (in %) of Belize in 2006 to that in 2011?
Ensure brevity in your answer.  0.75. What is the ratio of the Revenue generated (in %) of Jordan in 2006 to that in 2011?
Offer a very short reply. 0.56. What is the ratio of the Revenue generated (in %) in Togo in 2006 to that in 2011?
Offer a very short reply. 0.53. What is the ratio of the Revenue generated (in %) in Latin America(developing only) in 2007 to that in 2008?
Your answer should be compact. 0.92. What is the ratio of the Revenue generated (in %) in Belize in 2007 to that in 2008?
Provide a succinct answer. 0.87. What is the ratio of the Revenue generated (in %) of Jordan in 2007 to that in 2008?
Offer a terse response. 0.58. What is the ratio of the Revenue generated (in %) in Togo in 2007 to that in 2008?
Provide a succinct answer. 0.8. What is the ratio of the Revenue generated (in %) in Latin America(developing only) in 2007 to that in 2009?
Keep it short and to the point. 1.07. What is the ratio of the Revenue generated (in %) in Belize in 2007 to that in 2009?
Provide a short and direct response. 1.25. What is the ratio of the Revenue generated (in %) in Jordan in 2007 to that in 2009?
Offer a terse response. 0.67. What is the ratio of the Revenue generated (in %) in Togo in 2007 to that in 2009?
Provide a succinct answer. 0.44. What is the ratio of the Revenue generated (in %) of Latin America(developing only) in 2007 to that in 2010?
Provide a succinct answer. 1.07. What is the ratio of the Revenue generated (in %) of Belize in 2007 to that in 2010?
Your answer should be very brief. 1.32. What is the ratio of the Revenue generated (in %) of Jordan in 2007 to that in 2010?
Provide a short and direct response. 0.68. What is the ratio of the Revenue generated (in %) of Togo in 2007 to that in 2010?
Offer a very short reply. 0.47. What is the ratio of the Revenue generated (in %) in Latin America(developing only) in 2007 to that in 2011?
Provide a short and direct response. 1.16. What is the ratio of the Revenue generated (in %) in Belize in 2007 to that in 2011?
Provide a succinct answer. 1.01. What is the ratio of the Revenue generated (in %) in Jordan in 2007 to that in 2011?
Your answer should be compact. 0.56. What is the ratio of the Revenue generated (in %) of Togo in 2007 to that in 2011?
Make the answer very short. 0.45. What is the ratio of the Revenue generated (in %) of Latin America(developing only) in 2008 to that in 2009?
Give a very brief answer. 1.17. What is the ratio of the Revenue generated (in %) in Belize in 2008 to that in 2009?
Provide a short and direct response. 1.44. What is the ratio of the Revenue generated (in %) in Jordan in 2008 to that in 2009?
Make the answer very short. 1.15. What is the ratio of the Revenue generated (in %) of Togo in 2008 to that in 2009?
Your answer should be very brief. 0.55. What is the ratio of the Revenue generated (in %) of Latin America(developing only) in 2008 to that in 2010?
Offer a terse response. 1.17. What is the ratio of the Revenue generated (in %) in Belize in 2008 to that in 2010?
Offer a terse response. 1.52. What is the ratio of the Revenue generated (in %) of Jordan in 2008 to that in 2010?
Keep it short and to the point. 1.16. What is the ratio of the Revenue generated (in %) in Togo in 2008 to that in 2010?
Offer a terse response. 0.58. What is the ratio of the Revenue generated (in %) of Latin America(developing only) in 2008 to that in 2011?
Your answer should be very brief. 1.26. What is the ratio of the Revenue generated (in %) in Belize in 2008 to that in 2011?
Provide a succinct answer. 1.16. What is the ratio of the Revenue generated (in %) of Jordan in 2008 to that in 2011?
Your answer should be very brief. 0.96. What is the ratio of the Revenue generated (in %) of Togo in 2008 to that in 2011?
Give a very brief answer. 0.57. What is the ratio of the Revenue generated (in %) in Belize in 2009 to that in 2010?
Provide a short and direct response. 1.05. What is the ratio of the Revenue generated (in %) of Jordan in 2009 to that in 2010?
Offer a terse response. 1.01. What is the ratio of the Revenue generated (in %) in Togo in 2009 to that in 2010?
Provide a succinct answer. 1.05. What is the ratio of the Revenue generated (in %) of Latin America(developing only) in 2009 to that in 2011?
Give a very brief answer. 1.08. What is the ratio of the Revenue generated (in %) of Belize in 2009 to that in 2011?
Your answer should be compact. 0.81. What is the ratio of the Revenue generated (in %) of Jordan in 2009 to that in 2011?
Offer a terse response. 0.83. What is the ratio of the Revenue generated (in %) of Togo in 2009 to that in 2011?
Ensure brevity in your answer.  1.02. What is the ratio of the Revenue generated (in %) of Latin America(developing only) in 2010 to that in 2011?
Ensure brevity in your answer.  1.08. What is the ratio of the Revenue generated (in %) in Belize in 2010 to that in 2011?
Offer a terse response. 0.77. What is the ratio of the Revenue generated (in %) of Jordan in 2010 to that in 2011?
Keep it short and to the point. 0.82. What is the ratio of the Revenue generated (in %) in Togo in 2010 to that in 2011?
Provide a succinct answer. 0.97. What is the difference between the highest and the second highest Revenue generated (in %) of Latin America(developing only)?
Make the answer very short. 1.57. What is the difference between the highest and the second highest Revenue generated (in %) in Belize?
Make the answer very short. 3.1. What is the difference between the highest and the second highest Revenue generated (in %) of Jordan?
Provide a short and direct response. 1.71. What is the difference between the highest and the second highest Revenue generated (in %) in Togo?
Offer a terse response. 0.61. What is the difference between the highest and the lowest Revenue generated (in %) of Latin America(developing only)?
Keep it short and to the point. 3.88. What is the difference between the highest and the lowest Revenue generated (in %) in Belize?
Offer a very short reply. 8.37. What is the difference between the highest and the lowest Revenue generated (in %) of Jordan?
Your answer should be compact. 19.11. What is the difference between the highest and the lowest Revenue generated (in %) of Togo?
Offer a terse response. 22.74. 